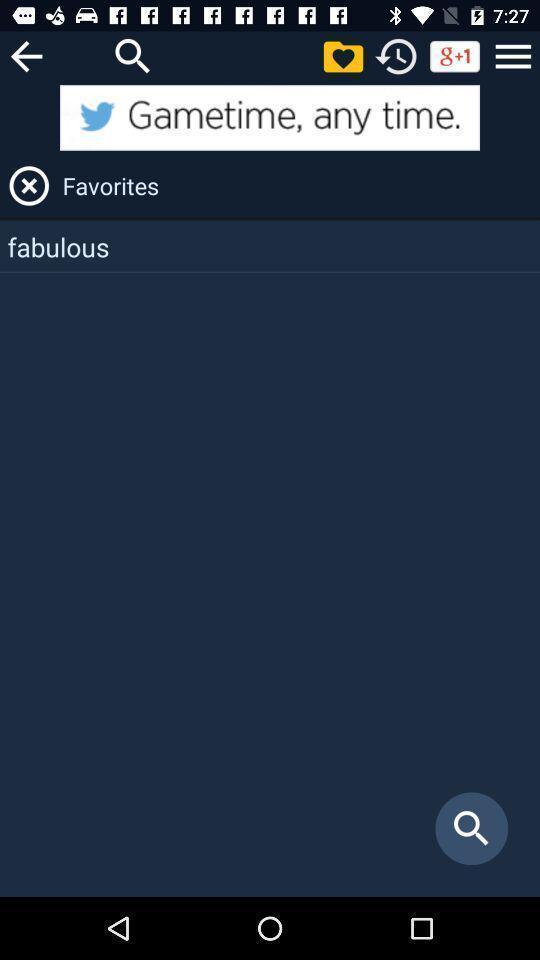Provide a textual representation of this image. Screen showing favorites page location. 